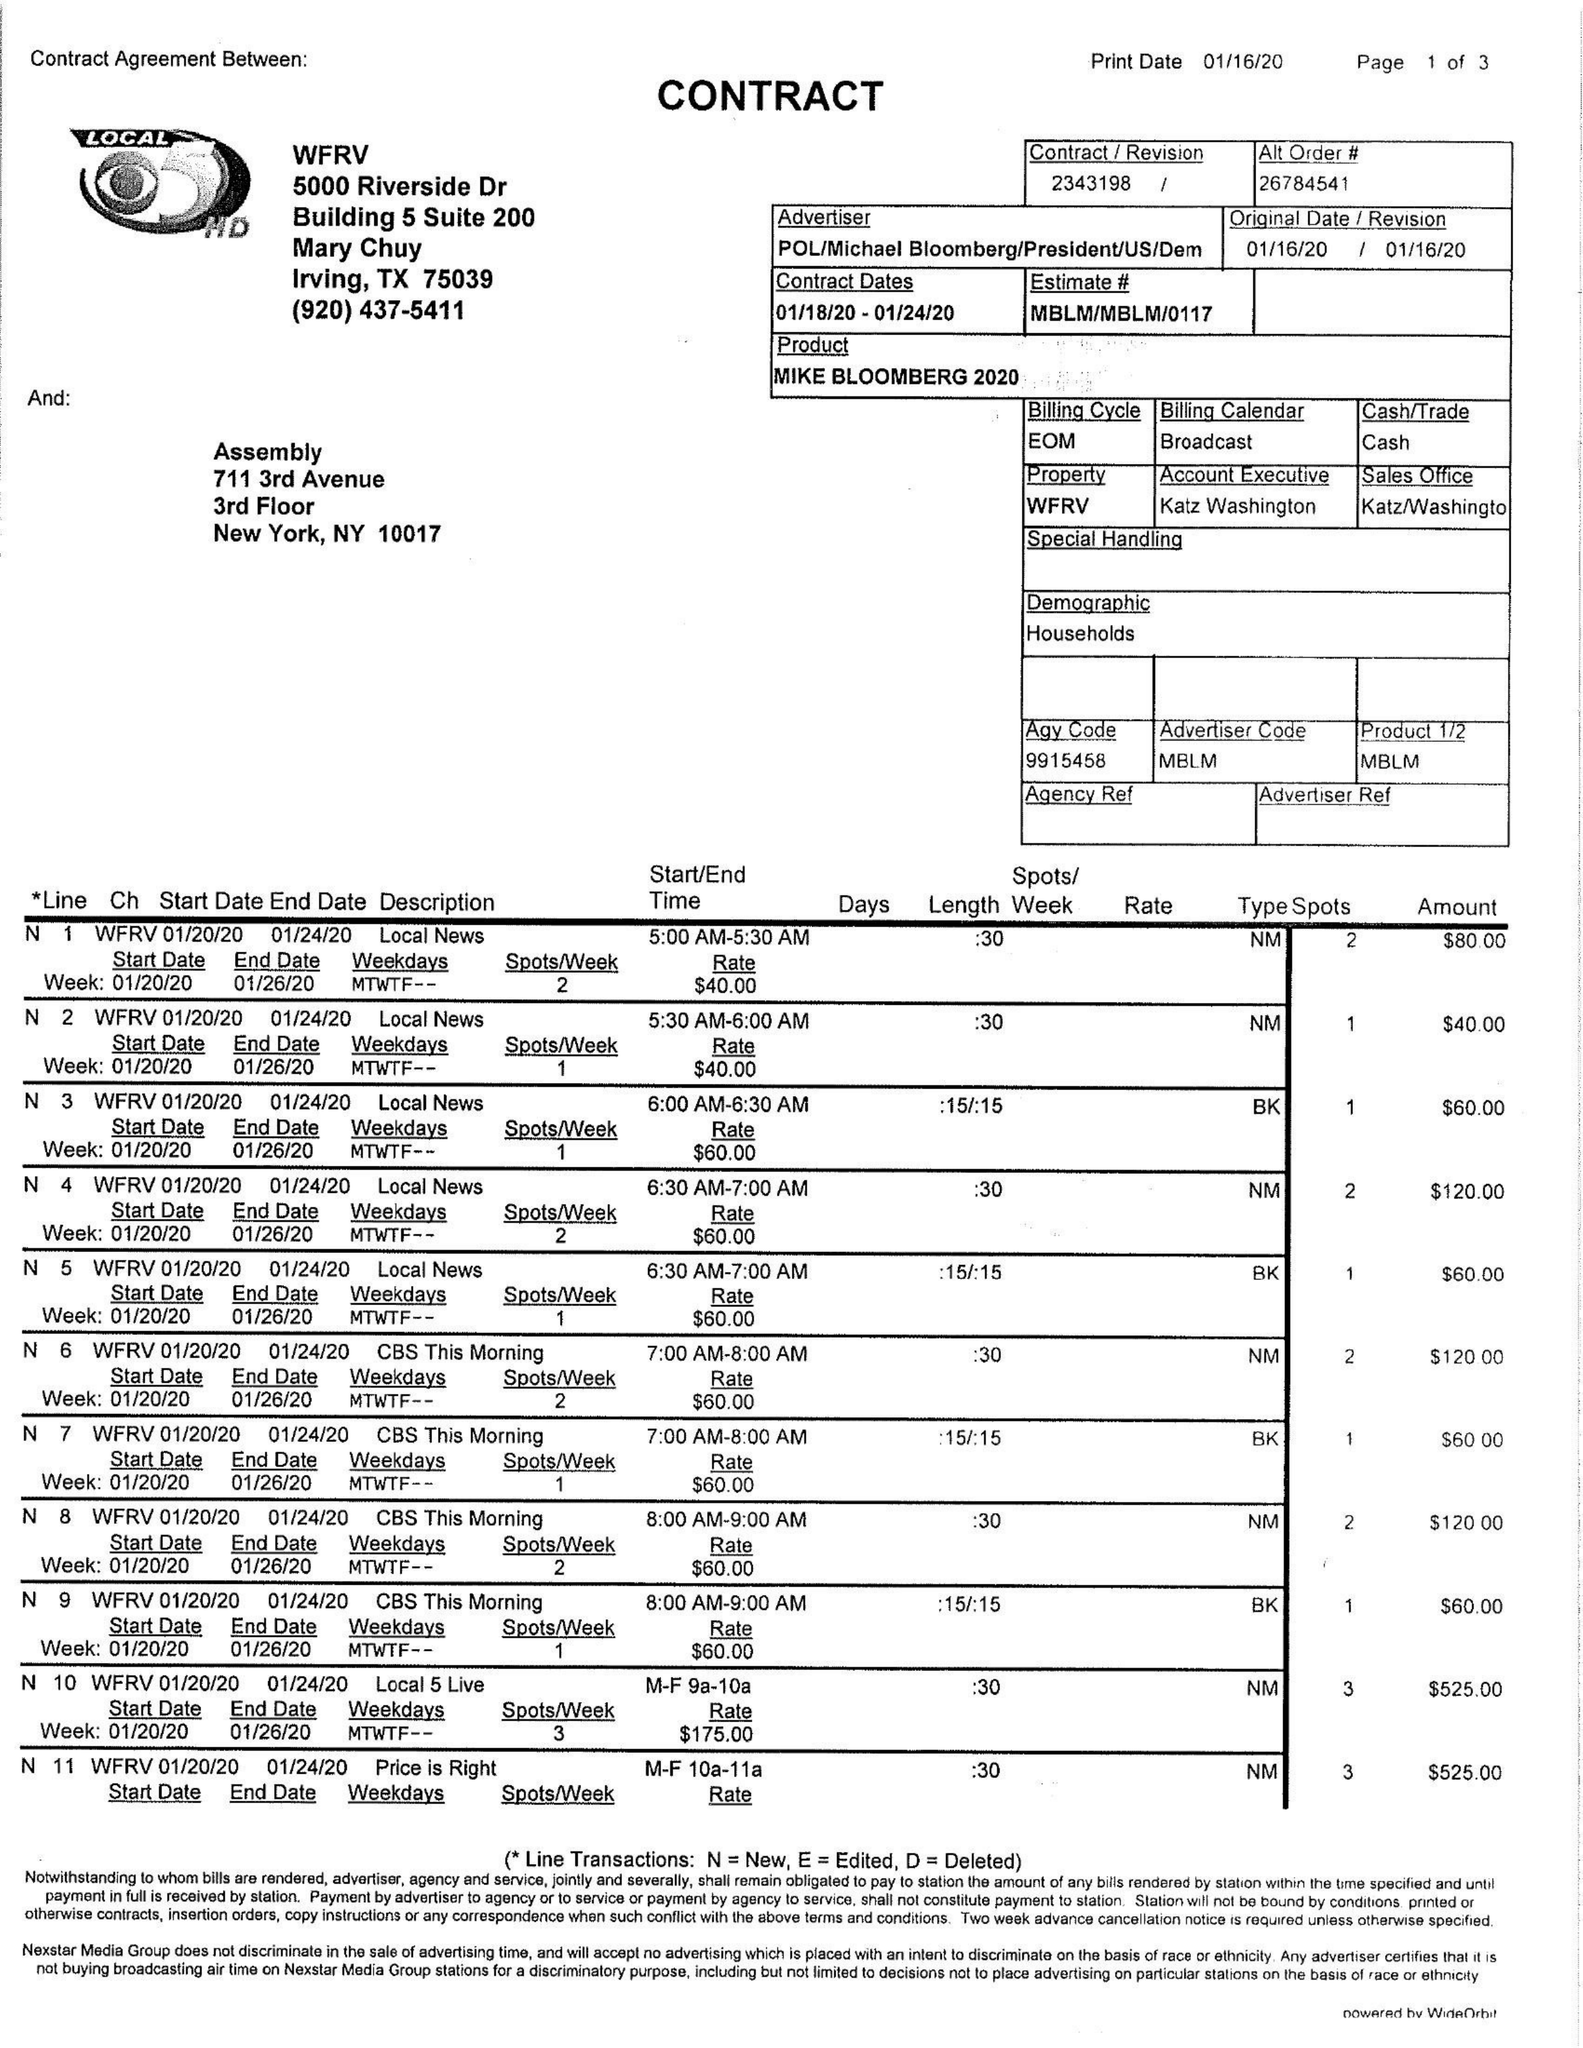What is the value for the gross_amount?
Answer the question using a single word or phrase. 19845.00 